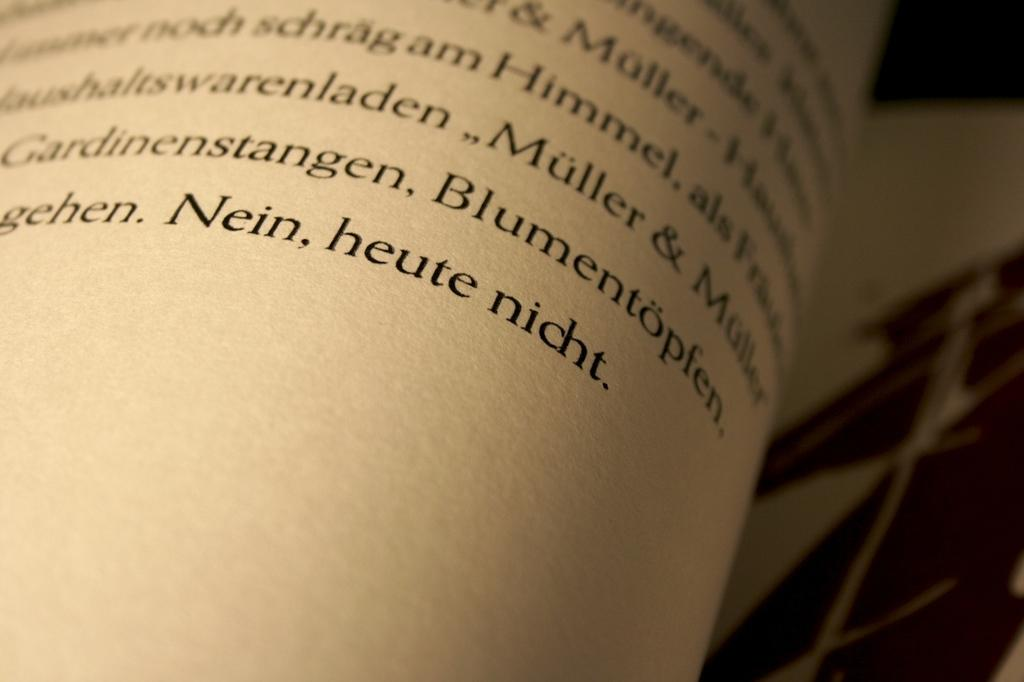<image>
Relay a brief, clear account of the picture shown. Nien, heute nicht is the last sentence in this book 